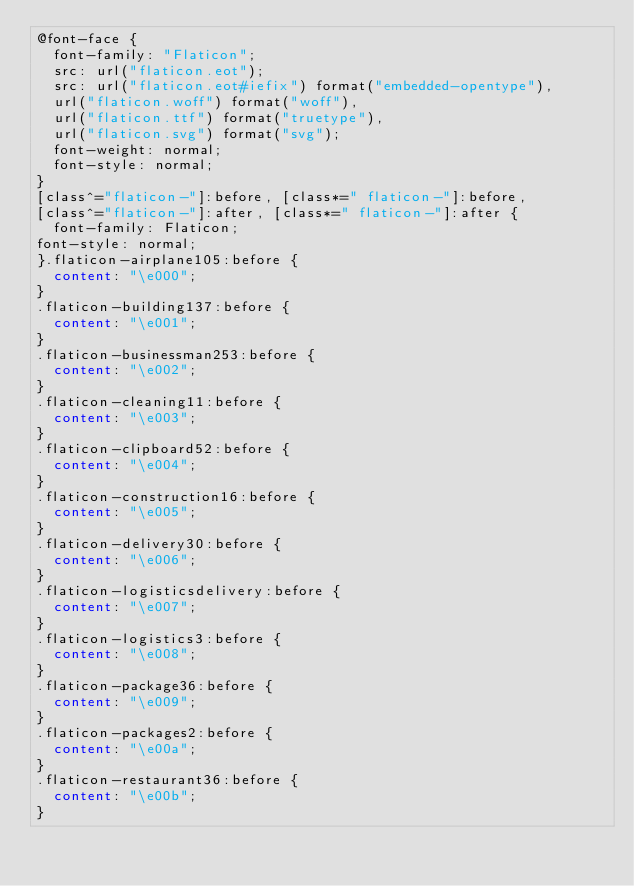<code> <loc_0><loc_0><loc_500><loc_500><_CSS_>@font-face {
	font-family: "Flaticon";
	src: url("flaticon.eot");
	src: url("flaticon.eot#iefix") format("embedded-opentype"),
	url("flaticon.woff") format("woff"),
	url("flaticon.ttf") format("truetype"),
	url("flaticon.svg") format("svg");
	font-weight: normal;
	font-style: normal;
}
[class^="flaticon-"]:before, [class*=" flaticon-"]:before,
[class^="flaticon-"]:after, [class*=" flaticon-"]:after {
	font-family: Flaticon;
font-style: normal;
}.flaticon-airplane105:before {
	content: "\e000";
}
.flaticon-building137:before {
	content: "\e001";
}
.flaticon-businessman253:before {
	content: "\e002";
}
.flaticon-cleaning11:before {
	content: "\e003";
}
.flaticon-clipboard52:before {
	content: "\e004";
}
.flaticon-construction16:before {
	content: "\e005";
}
.flaticon-delivery30:before {
	content: "\e006";
}
.flaticon-logisticsdelivery:before {
	content: "\e007";
}
.flaticon-logistics3:before {
	content: "\e008";
}
.flaticon-package36:before {
	content: "\e009";
}
.flaticon-packages2:before {
	content: "\e00a";
}
.flaticon-restaurant36:before {
	content: "\e00b";
}
</code> 